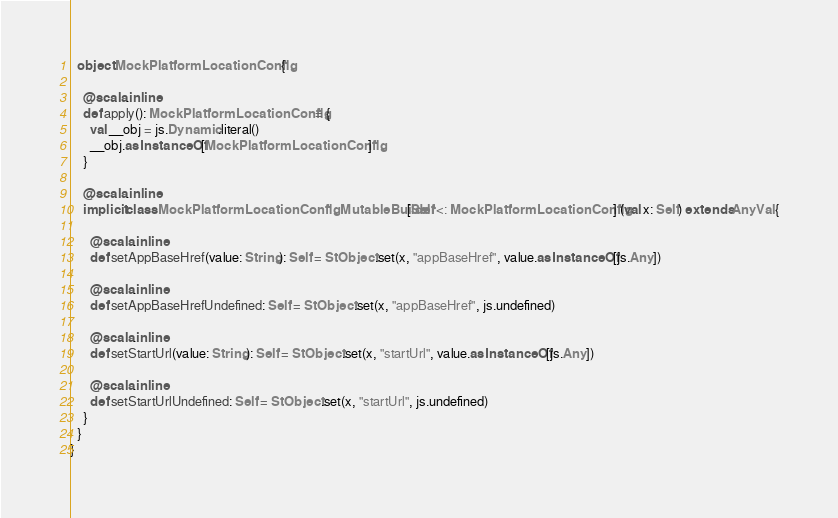<code> <loc_0><loc_0><loc_500><loc_500><_Scala_>  object MockPlatformLocationConfig {
    
    @scala.inline
    def apply(): MockPlatformLocationConfig = {
      val __obj = js.Dynamic.literal()
      __obj.asInstanceOf[MockPlatformLocationConfig]
    }
    
    @scala.inline
    implicit class MockPlatformLocationConfigMutableBuilder[Self <: MockPlatformLocationConfig] (val x: Self) extends AnyVal {
      
      @scala.inline
      def setAppBaseHref(value: String): Self = StObject.set(x, "appBaseHref", value.asInstanceOf[js.Any])
      
      @scala.inline
      def setAppBaseHrefUndefined: Self = StObject.set(x, "appBaseHref", js.undefined)
      
      @scala.inline
      def setStartUrl(value: String): Self = StObject.set(x, "startUrl", value.asInstanceOf[js.Any])
      
      @scala.inline
      def setStartUrlUndefined: Self = StObject.set(x, "startUrl", js.undefined)
    }
  }
}
</code> 